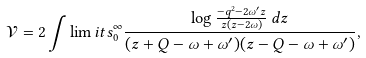<formula> <loc_0><loc_0><loc_500><loc_500>\mathcal { V } = 2 \int \lim i t s _ { 0 } ^ { \infty } \frac { \log \frac { - q ^ { 2 } - 2 \omega ^ { \prime } z } { z ( z - 2 \omega ) } \, d z } { ( z + Q - \omega + \omega ^ { \prime } ) ( z - Q - \omega + \omega ^ { \prime } ) } ,</formula> 